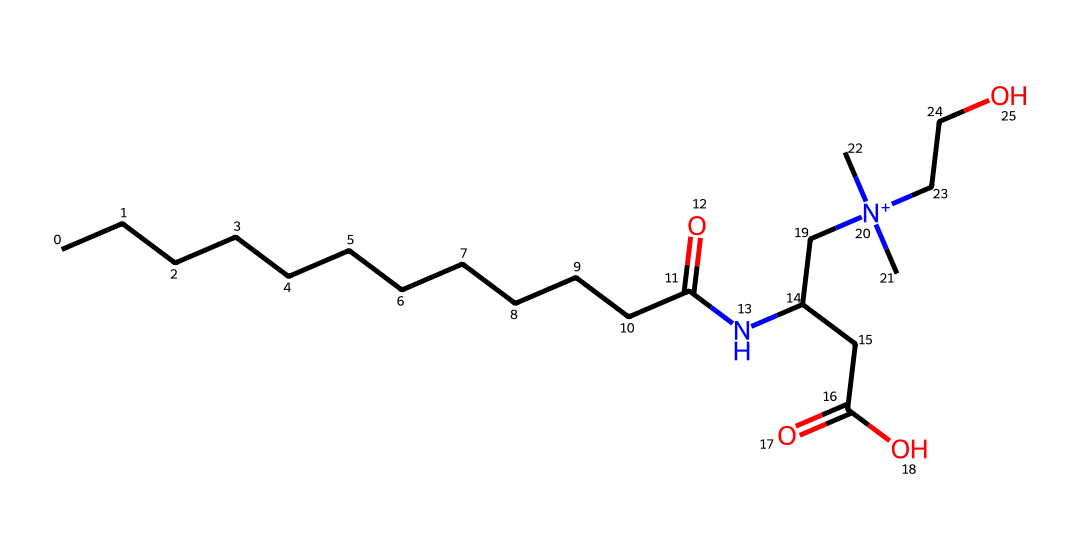What is the molecular formula of cocamidopropyl betaine? To find the molecular formula, we count the number of each type of atom present in the structure. The count includes: 15 carbons (C), 30 hydrogens (H), 2 nitrogens (N), and 3 oxygens (O). Thus, the molecular formula is C15H30N2O3.
Answer: C15H30N2O3 How many nitrogen atoms are in this chemical? By examining the structure, we can identify the nitrogen atoms. There are two distinct nitrogen atoms (one in the amide and another in the quaternary ammonium group).
Answer: 2 What functional groups are present in this molecule? Identifying the functional groups requires knowledge of common groups. The structure shows an amide group (-C(=O)N-), a carboxylic acid group (-C(=O)O), and a quaternary ammonium group (-N+(C)(C)(C)-) among others, indicating the presence of several functional groups.
Answer: amide, carboxylic acid, quaternary ammonium What aspect of this chemical makes it a surfactant? Surfactants typically possess both hydrophilic (water-attracting) and hydrophobic (water-repelling) characteristics. This molecule contains a long hydrophobic carbon chain and a hydrophilic quaternary ammonium end, providing the necessary amphiphilic nature typical of surfactants.
Answer: amphiphilic nature How does the structure indicate gently in hand soaps? The presence of a large fatty acid tail and mild functional groups gives this surfactant a gentle characteristic, suitable for skin. The cocamidopropyl portion indicates it is derived from coconut oil, known for its mildness, making it non-irritating for sensitive skin.
Answer: mildness 